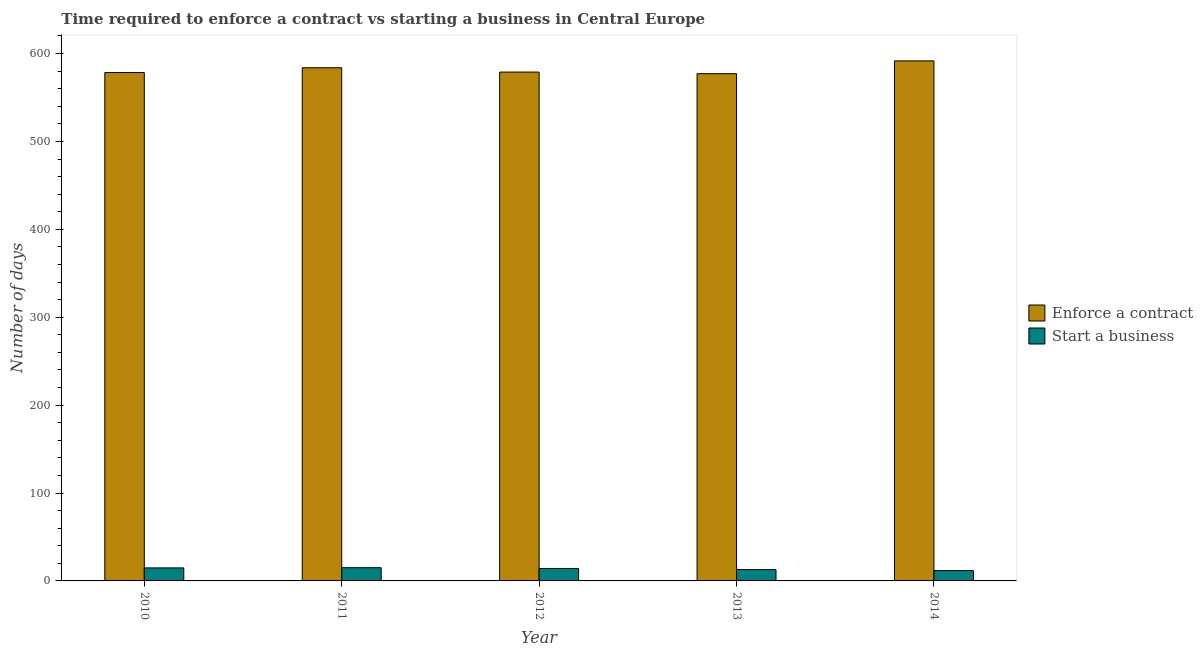How many different coloured bars are there?
Provide a short and direct response. 2. How many groups of bars are there?
Your answer should be very brief. 5. What is the label of the 4th group of bars from the left?
Give a very brief answer. 2013. In how many cases, is the number of bars for a given year not equal to the number of legend labels?
Your answer should be very brief. 0. What is the number of days to enforece a contract in 2013?
Ensure brevity in your answer.  577.09. Across all years, what is the maximum number of days to enforece a contract?
Your answer should be very brief. 591.64. Across all years, what is the minimum number of days to start a business?
Provide a short and direct response. 11.77. In which year was the number of days to start a business minimum?
Offer a very short reply. 2014. What is the total number of days to start a business in the graph?
Provide a succinct answer. 68.73. What is the difference between the number of days to enforece a contract in 2011 and that in 2012?
Provide a succinct answer. 4.91. What is the difference between the number of days to enforece a contract in 2012 and the number of days to start a business in 2013?
Your answer should be very brief. 1.82. What is the average number of days to enforece a contract per year?
Offer a very short reply. 581.96. What is the ratio of the number of days to start a business in 2011 to that in 2012?
Offer a terse response. 1.06. Is the difference between the number of days to enforece a contract in 2013 and 2014 greater than the difference between the number of days to start a business in 2013 and 2014?
Your response must be concise. No. What is the difference between the highest and the second highest number of days to start a business?
Give a very brief answer. 0.23. What is the difference between the highest and the lowest number of days to enforece a contract?
Offer a terse response. 14.55. Is the sum of the number of days to enforece a contract in 2010 and 2014 greater than the maximum number of days to start a business across all years?
Keep it short and to the point. Yes. What does the 1st bar from the left in 2014 represents?
Ensure brevity in your answer.  Enforce a contract. What does the 2nd bar from the right in 2012 represents?
Your answer should be very brief. Enforce a contract. Are the values on the major ticks of Y-axis written in scientific E-notation?
Make the answer very short. No. Does the graph contain any zero values?
Your answer should be compact. No. What is the title of the graph?
Keep it short and to the point. Time required to enforce a contract vs starting a business in Central Europe. What is the label or title of the Y-axis?
Your answer should be compact. Number of days. What is the Number of days in Enforce a contract in 2010?
Your response must be concise. 578.36. What is the Number of days of Start a business in 2010?
Your answer should be compact. 14.82. What is the Number of days of Enforce a contract in 2011?
Keep it short and to the point. 583.82. What is the Number of days of Start a business in 2011?
Offer a terse response. 15.05. What is the Number of days in Enforce a contract in 2012?
Provide a succinct answer. 578.91. What is the Number of days of Start a business in 2012?
Make the answer very short. 14.18. What is the Number of days in Enforce a contract in 2013?
Your response must be concise. 577.09. What is the Number of days of Start a business in 2013?
Provide a short and direct response. 12.91. What is the Number of days of Enforce a contract in 2014?
Provide a short and direct response. 591.64. What is the Number of days of Start a business in 2014?
Ensure brevity in your answer.  11.77. Across all years, what is the maximum Number of days in Enforce a contract?
Provide a short and direct response. 591.64. Across all years, what is the maximum Number of days of Start a business?
Offer a terse response. 15.05. Across all years, what is the minimum Number of days of Enforce a contract?
Provide a short and direct response. 577.09. Across all years, what is the minimum Number of days of Start a business?
Ensure brevity in your answer.  11.77. What is the total Number of days of Enforce a contract in the graph?
Your answer should be compact. 2909.82. What is the total Number of days in Start a business in the graph?
Offer a very short reply. 68.73. What is the difference between the Number of days of Enforce a contract in 2010 and that in 2011?
Keep it short and to the point. -5.45. What is the difference between the Number of days in Start a business in 2010 and that in 2011?
Offer a very short reply. -0.23. What is the difference between the Number of days of Enforce a contract in 2010 and that in 2012?
Provide a succinct answer. -0.55. What is the difference between the Number of days in Start a business in 2010 and that in 2012?
Offer a very short reply. 0.64. What is the difference between the Number of days of Enforce a contract in 2010 and that in 2013?
Keep it short and to the point. 1.27. What is the difference between the Number of days of Start a business in 2010 and that in 2013?
Offer a very short reply. 1.91. What is the difference between the Number of days in Enforce a contract in 2010 and that in 2014?
Ensure brevity in your answer.  -13.27. What is the difference between the Number of days of Start a business in 2010 and that in 2014?
Your answer should be very brief. 3.05. What is the difference between the Number of days of Enforce a contract in 2011 and that in 2012?
Provide a succinct answer. 4.91. What is the difference between the Number of days in Start a business in 2011 and that in 2012?
Keep it short and to the point. 0.86. What is the difference between the Number of days in Enforce a contract in 2011 and that in 2013?
Ensure brevity in your answer.  6.73. What is the difference between the Number of days of Start a business in 2011 and that in 2013?
Give a very brief answer. 2.14. What is the difference between the Number of days of Enforce a contract in 2011 and that in 2014?
Your response must be concise. -7.82. What is the difference between the Number of days in Start a business in 2011 and that in 2014?
Offer a very short reply. 3.27. What is the difference between the Number of days of Enforce a contract in 2012 and that in 2013?
Provide a succinct answer. 1.82. What is the difference between the Number of days in Start a business in 2012 and that in 2013?
Keep it short and to the point. 1.27. What is the difference between the Number of days in Enforce a contract in 2012 and that in 2014?
Give a very brief answer. -12.73. What is the difference between the Number of days in Start a business in 2012 and that in 2014?
Provide a short and direct response. 2.41. What is the difference between the Number of days of Enforce a contract in 2013 and that in 2014?
Your response must be concise. -14.55. What is the difference between the Number of days of Start a business in 2013 and that in 2014?
Give a very brief answer. 1.14. What is the difference between the Number of days of Enforce a contract in 2010 and the Number of days of Start a business in 2011?
Provide a short and direct response. 563.32. What is the difference between the Number of days of Enforce a contract in 2010 and the Number of days of Start a business in 2012?
Your answer should be very brief. 564.18. What is the difference between the Number of days of Enforce a contract in 2010 and the Number of days of Start a business in 2013?
Ensure brevity in your answer.  565.45. What is the difference between the Number of days in Enforce a contract in 2010 and the Number of days in Start a business in 2014?
Ensure brevity in your answer.  566.59. What is the difference between the Number of days of Enforce a contract in 2011 and the Number of days of Start a business in 2012?
Your response must be concise. 569.64. What is the difference between the Number of days in Enforce a contract in 2011 and the Number of days in Start a business in 2013?
Offer a very short reply. 570.91. What is the difference between the Number of days of Enforce a contract in 2011 and the Number of days of Start a business in 2014?
Offer a terse response. 572.05. What is the difference between the Number of days of Enforce a contract in 2012 and the Number of days of Start a business in 2013?
Your answer should be very brief. 566. What is the difference between the Number of days in Enforce a contract in 2012 and the Number of days in Start a business in 2014?
Keep it short and to the point. 567.14. What is the difference between the Number of days in Enforce a contract in 2013 and the Number of days in Start a business in 2014?
Your answer should be compact. 565.32. What is the average Number of days of Enforce a contract per year?
Your answer should be very brief. 581.96. What is the average Number of days of Start a business per year?
Make the answer very short. 13.75. In the year 2010, what is the difference between the Number of days of Enforce a contract and Number of days of Start a business?
Provide a succinct answer. 563.55. In the year 2011, what is the difference between the Number of days of Enforce a contract and Number of days of Start a business?
Ensure brevity in your answer.  568.77. In the year 2012, what is the difference between the Number of days in Enforce a contract and Number of days in Start a business?
Give a very brief answer. 564.73. In the year 2013, what is the difference between the Number of days in Enforce a contract and Number of days in Start a business?
Ensure brevity in your answer.  564.18. In the year 2014, what is the difference between the Number of days of Enforce a contract and Number of days of Start a business?
Keep it short and to the point. 579.86. What is the ratio of the Number of days in Enforce a contract in 2010 to that in 2011?
Make the answer very short. 0.99. What is the ratio of the Number of days in Start a business in 2010 to that in 2011?
Make the answer very short. 0.98. What is the ratio of the Number of days in Enforce a contract in 2010 to that in 2012?
Your answer should be very brief. 1. What is the ratio of the Number of days in Start a business in 2010 to that in 2012?
Your answer should be very brief. 1.04. What is the ratio of the Number of days in Enforce a contract in 2010 to that in 2013?
Your answer should be compact. 1. What is the ratio of the Number of days in Start a business in 2010 to that in 2013?
Make the answer very short. 1.15. What is the ratio of the Number of days of Enforce a contract in 2010 to that in 2014?
Offer a very short reply. 0.98. What is the ratio of the Number of days of Start a business in 2010 to that in 2014?
Your answer should be compact. 1.26. What is the ratio of the Number of days in Enforce a contract in 2011 to that in 2012?
Provide a short and direct response. 1.01. What is the ratio of the Number of days in Start a business in 2011 to that in 2012?
Provide a succinct answer. 1.06. What is the ratio of the Number of days of Enforce a contract in 2011 to that in 2013?
Keep it short and to the point. 1.01. What is the ratio of the Number of days of Start a business in 2011 to that in 2013?
Offer a very short reply. 1.17. What is the ratio of the Number of days of Start a business in 2011 to that in 2014?
Ensure brevity in your answer.  1.28. What is the ratio of the Number of days of Start a business in 2012 to that in 2013?
Provide a short and direct response. 1.1. What is the ratio of the Number of days of Enforce a contract in 2012 to that in 2014?
Offer a terse response. 0.98. What is the ratio of the Number of days of Start a business in 2012 to that in 2014?
Your response must be concise. 1.2. What is the ratio of the Number of days of Enforce a contract in 2013 to that in 2014?
Keep it short and to the point. 0.98. What is the ratio of the Number of days in Start a business in 2013 to that in 2014?
Provide a succinct answer. 1.1. What is the difference between the highest and the second highest Number of days in Enforce a contract?
Make the answer very short. 7.82. What is the difference between the highest and the second highest Number of days in Start a business?
Your response must be concise. 0.23. What is the difference between the highest and the lowest Number of days of Enforce a contract?
Offer a very short reply. 14.55. What is the difference between the highest and the lowest Number of days in Start a business?
Provide a succinct answer. 3.27. 